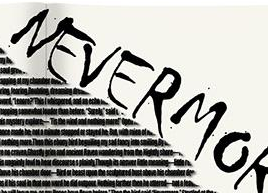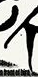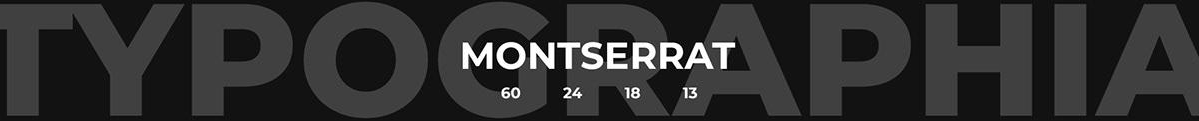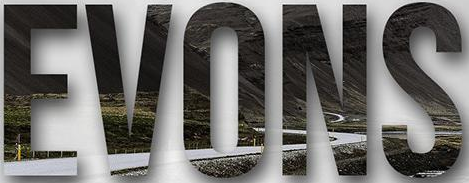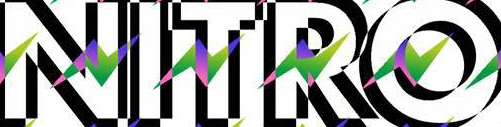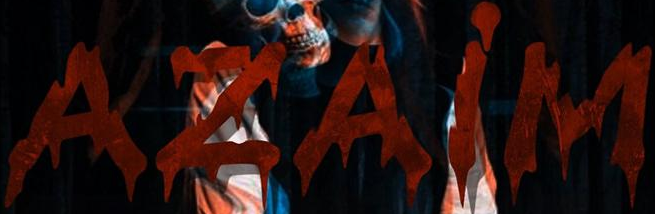What text is displayed in these images sequentially, separated by a semicolon? NEVERMO; #; TYPOGRAPHIA; EVONS; NITRO; AZAiM 